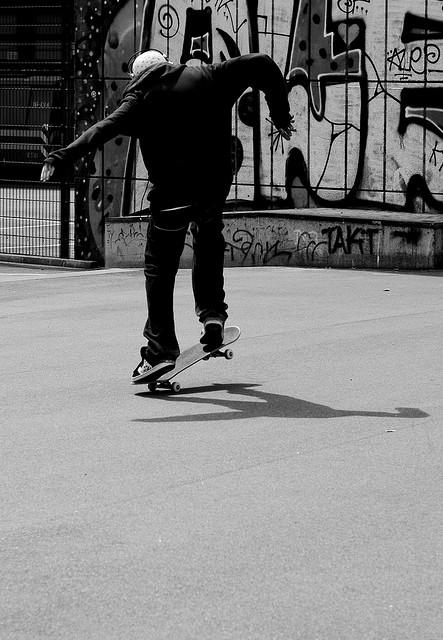Is the photo colored?
Concise answer only. No. Are all 4 wheels on the ground?
Concise answer only. No. Is there a skateboard?
Concise answer only. Yes. 